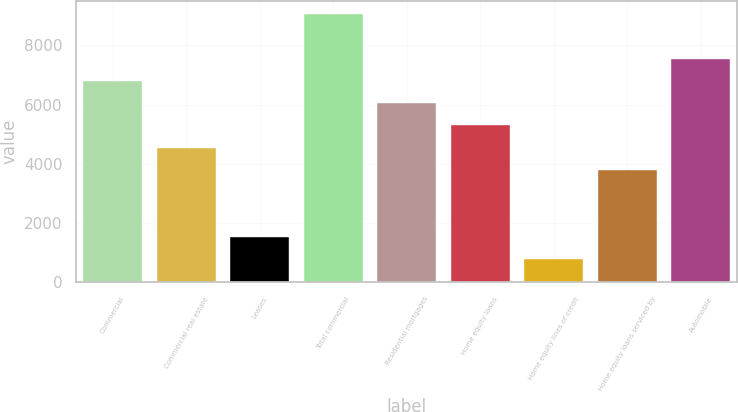<chart> <loc_0><loc_0><loc_500><loc_500><bar_chart><fcel>Commercial<fcel>Commercial real estate<fcel>Leases<fcel>Total commercial<fcel>Residential mortgages<fcel>Home equity loans<fcel>Home equity lines of credit<fcel>Home equity loans serviced by<fcel>Automobile<nl><fcel>6800.7<fcel>4549.8<fcel>1548.6<fcel>9051.6<fcel>6050.4<fcel>5300.1<fcel>798.3<fcel>3799.5<fcel>7551<nl></chart> 